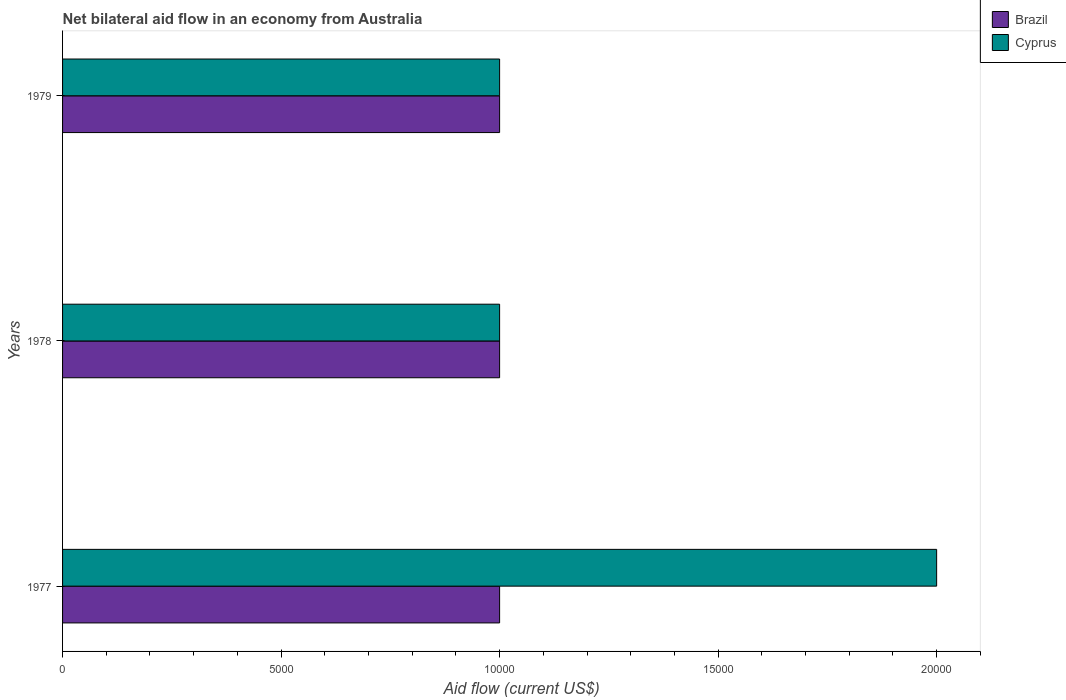Are the number of bars per tick equal to the number of legend labels?
Ensure brevity in your answer.  Yes. How many bars are there on the 2nd tick from the top?
Ensure brevity in your answer.  2. What is the label of the 1st group of bars from the top?
Provide a short and direct response. 1979. What is the net bilateral aid flow in Brazil in 1977?
Offer a very short reply. 10000. Across all years, what is the maximum net bilateral aid flow in Cyprus?
Provide a succinct answer. 2.00e+04. Across all years, what is the minimum net bilateral aid flow in Cyprus?
Offer a very short reply. 10000. In which year was the net bilateral aid flow in Cyprus minimum?
Offer a terse response. 1978. What is the total net bilateral aid flow in Brazil in the graph?
Offer a very short reply. 3.00e+04. What is the difference between the net bilateral aid flow in Brazil in 1978 and that in 1979?
Keep it short and to the point. 0. Is the difference between the net bilateral aid flow in Cyprus in 1977 and 1978 greater than the difference between the net bilateral aid flow in Brazil in 1977 and 1978?
Your answer should be compact. Yes. What is the difference between the highest and the lowest net bilateral aid flow in Cyprus?
Your answer should be compact. 10000. In how many years, is the net bilateral aid flow in Cyprus greater than the average net bilateral aid flow in Cyprus taken over all years?
Provide a short and direct response. 1. Is the sum of the net bilateral aid flow in Brazil in 1977 and 1979 greater than the maximum net bilateral aid flow in Cyprus across all years?
Make the answer very short. No. What does the 2nd bar from the top in 1977 represents?
Your response must be concise. Brazil. What does the 2nd bar from the bottom in 1978 represents?
Your answer should be compact. Cyprus. Are all the bars in the graph horizontal?
Keep it short and to the point. Yes. How many years are there in the graph?
Provide a short and direct response. 3. Does the graph contain any zero values?
Give a very brief answer. No. Where does the legend appear in the graph?
Offer a very short reply. Top right. How are the legend labels stacked?
Provide a succinct answer. Vertical. What is the title of the graph?
Give a very brief answer. Net bilateral aid flow in an economy from Australia. Does "Solomon Islands" appear as one of the legend labels in the graph?
Give a very brief answer. No. What is the label or title of the Y-axis?
Make the answer very short. Years. What is the Aid flow (current US$) in Brazil in 1977?
Ensure brevity in your answer.  10000. What is the Aid flow (current US$) in Cyprus in 1977?
Keep it short and to the point. 2.00e+04. What is the Aid flow (current US$) in Brazil in 1978?
Keep it short and to the point. 10000. What is the Aid flow (current US$) of Cyprus in 1978?
Keep it short and to the point. 10000. What is the Aid flow (current US$) of Cyprus in 1979?
Make the answer very short. 10000. Across all years, what is the maximum Aid flow (current US$) in Cyprus?
Offer a terse response. 2.00e+04. Across all years, what is the minimum Aid flow (current US$) of Brazil?
Provide a short and direct response. 10000. Across all years, what is the minimum Aid flow (current US$) of Cyprus?
Offer a terse response. 10000. What is the total Aid flow (current US$) in Brazil in the graph?
Provide a short and direct response. 3.00e+04. What is the total Aid flow (current US$) of Cyprus in the graph?
Offer a very short reply. 4.00e+04. What is the difference between the Aid flow (current US$) in Brazil in 1977 and that in 1978?
Give a very brief answer. 0. What is the difference between the Aid flow (current US$) in Brazil in 1977 and that in 1979?
Make the answer very short. 0. What is the difference between the Aid flow (current US$) in Brazil in 1977 and the Aid flow (current US$) in Cyprus in 1978?
Ensure brevity in your answer.  0. What is the average Aid flow (current US$) of Brazil per year?
Ensure brevity in your answer.  10000. What is the average Aid flow (current US$) of Cyprus per year?
Make the answer very short. 1.33e+04. In the year 1978, what is the difference between the Aid flow (current US$) in Brazil and Aid flow (current US$) in Cyprus?
Provide a short and direct response. 0. In the year 1979, what is the difference between the Aid flow (current US$) in Brazil and Aid flow (current US$) in Cyprus?
Offer a very short reply. 0. What is the ratio of the Aid flow (current US$) in Brazil in 1977 to that in 1978?
Your answer should be very brief. 1. What is the ratio of the Aid flow (current US$) in Cyprus in 1977 to that in 1978?
Give a very brief answer. 2. What is the difference between the highest and the second highest Aid flow (current US$) in Brazil?
Provide a succinct answer. 0. What is the difference between the highest and the lowest Aid flow (current US$) of Brazil?
Make the answer very short. 0. What is the difference between the highest and the lowest Aid flow (current US$) in Cyprus?
Ensure brevity in your answer.  10000. 